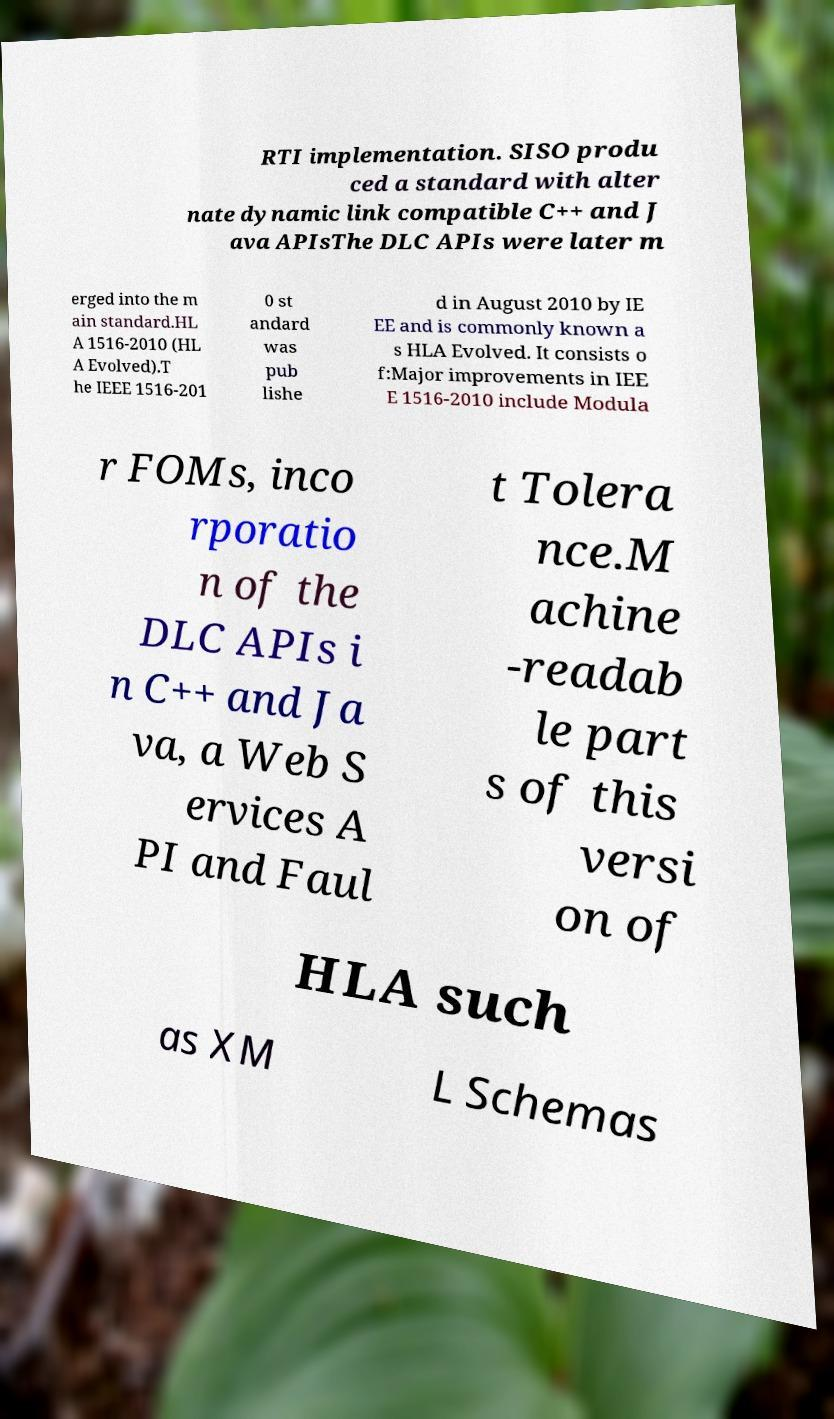There's text embedded in this image that I need extracted. Can you transcribe it verbatim? RTI implementation. SISO produ ced a standard with alter nate dynamic link compatible C++ and J ava APIsThe DLC APIs were later m erged into the m ain standard.HL A 1516-2010 (HL A Evolved).T he IEEE 1516-201 0 st andard was pub lishe d in August 2010 by IE EE and is commonly known a s HLA Evolved. It consists o f:Major improvements in IEE E 1516-2010 include Modula r FOMs, inco rporatio n of the DLC APIs i n C++ and Ja va, a Web S ervices A PI and Faul t Tolera nce.M achine -readab le part s of this versi on of HLA such as XM L Schemas 